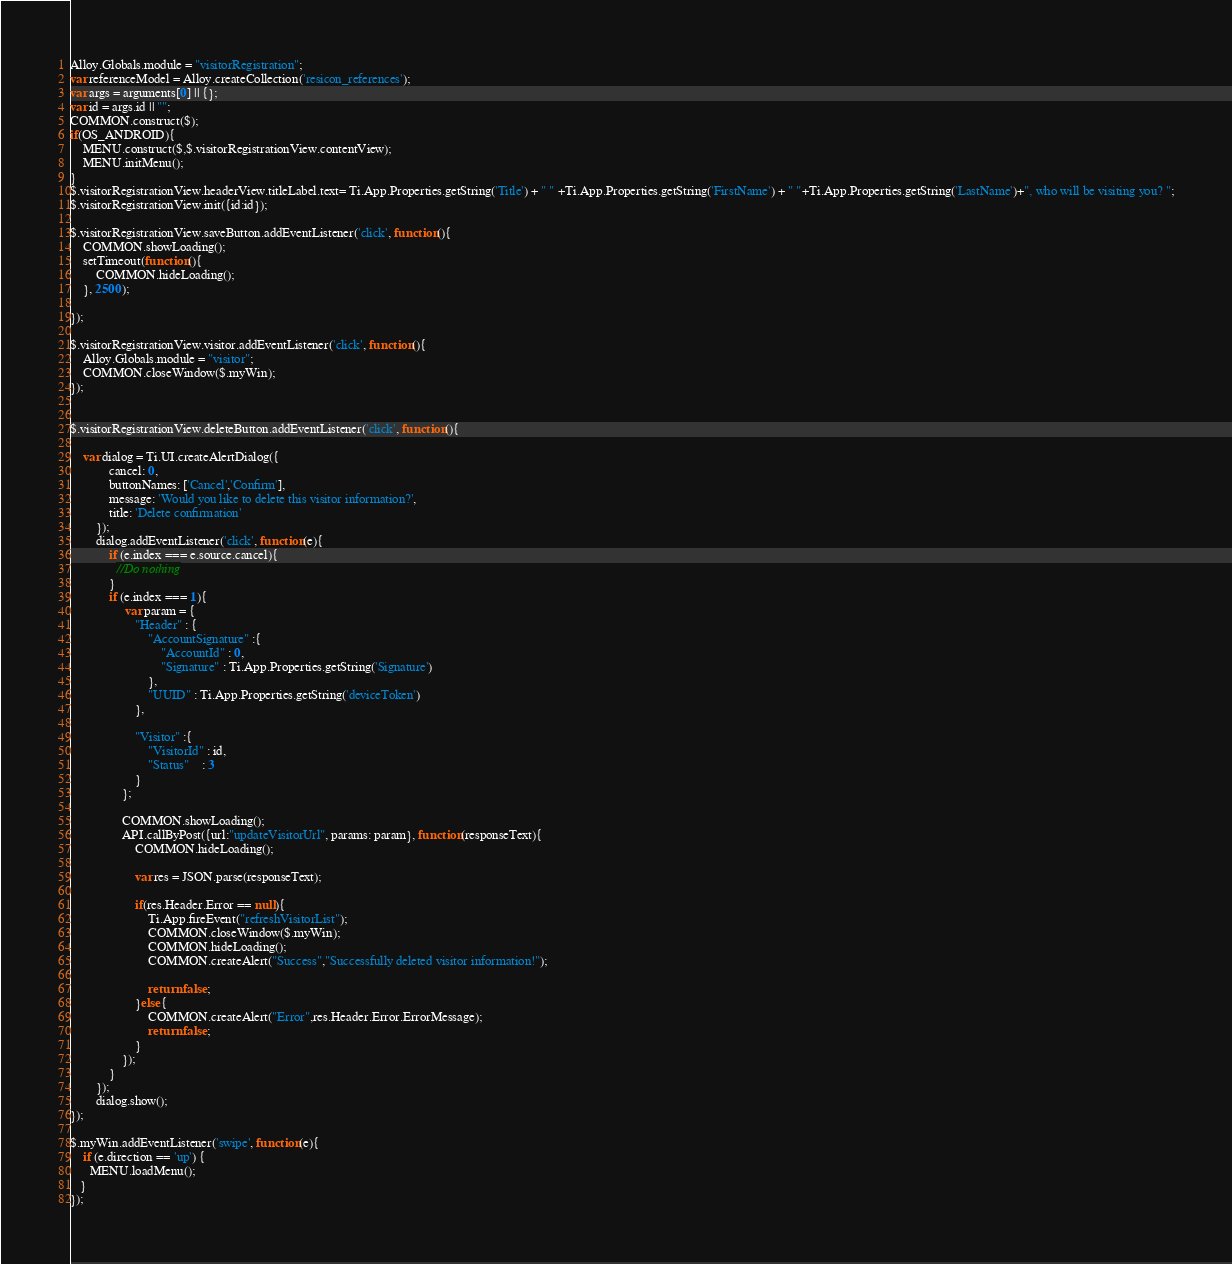Convert code to text. <code><loc_0><loc_0><loc_500><loc_500><_JavaScript_>Alloy.Globals.module = "visitorRegistration";
var referenceModel = Alloy.createCollection('resicon_references');  
var args = arguments[0] || {};
var id = args.id || "";
COMMON.construct($); 
if(OS_ANDROID){
	MENU.construct($,$.visitorRegistrationView.contentView);  
	MENU.initMenu();
} 
$.visitorRegistrationView.headerView.titleLabel.text= Ti.App.Properties.getString('Title') + " " +Ti.App.Properties.getString('FirstName') + " "+Ti.App.Properties.getString('LastName')+", who will be visiting you? ";
$.visitorRegistrationView.init({id:id}); 
 
$.visitorRegistrationView.saveButton.addEventListener('click', function(){
	COMMON.showLoading();
	setTimeout(function(){
		COMMON.hideLoading(); 
	}, 2500);
	 
}); 

$.visitorRegistrationView.visitor.addEventListener('click', function(){ 
	Alloy.Globals.module = "visitor";
	COMMON.closeWindow($.myWin); 
});


$.visitorRegistrationView.deleteButton.addEventListener('click', function(){
	
	var dialog = Ti.UI.createAlertDialog({
		    cancel: 0,
		    buttonNames: ['Cancel','Confirm'],
		    message: 'Would you like to delete this visitor information?',
		    title: 'Delete confirmation'
		});
		dialog.addEventListener('click', function(e){  
			if (e.index === e.source.cancel){
		      //Do nothing
		    }
		    if (e.index === 1){
		    	 var param = {
					"Header" : {
						"AccountSignature" :{
							"AccountId" : 0,
							"Signature" : Ti.App.Properties.getString('Signature')
						},
						"UUID" : Ti.App.Properties.getString('deviceToken')
					},
					
					"Visitor" :{
						"VisitorId" : id,
						"Status"    : 3
					} 
				};
				 
				COMMON.showLoading();  
				API.callByPost({url:"updateVisitorUrl", params: param}, function(responseText){
					COMMON.hideLoading();
				 
					var res = JSON.parse(responseText); 
					
					if(res.Header.Error == null){
						Ti.App.fireEvent("refreshVisitorList");
						COMMON.closeWindow($.myWin); 
						COMMON.hideLoading();
						COMMON.createAlert("Success","Successfully deleted visitor information!");
						
						return false;
					}else{
						COMMON.createAlert("Error",res.Header.Error.ErrorMessage);
						return false;
					} 
				});
		    }
		});
		dialog.show(); 
});
  
$.myWin.addEventListener('swipe', function(e){
	if (e.direction == 'up') {
      MENU.loadMenu();
   } 
});</code> 